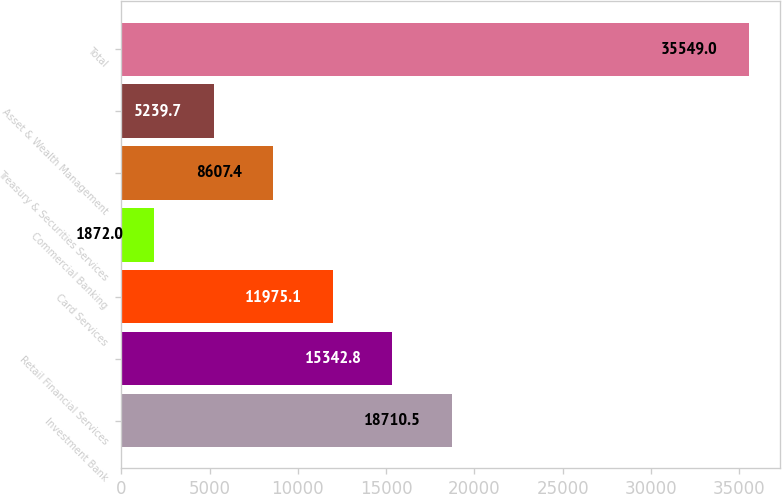Convert chart to OTSL. <chart><loc_0><loc_0><loc_500><loc_500><bar_chart><fcel>Investment Bank<fcel>Retail Financial Services<fcel>Card Services<fcel>Commercial Banking<fcel>Treasury & Securities Services<fcel>Asset & Wealth Management<fcel>Total<nl><fcel>18710.5<fcel>15342.8<fcel>11975.1<fcel>1872<fcel>8607.4<fcel>5239.7<fcel>35549<nl></chart> 